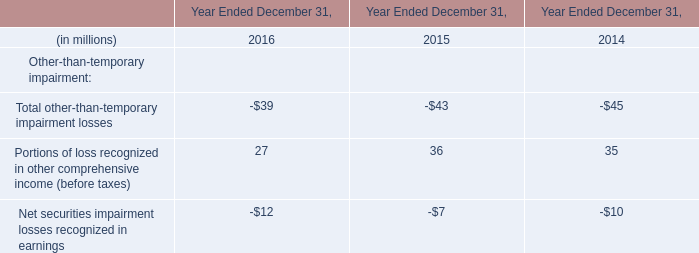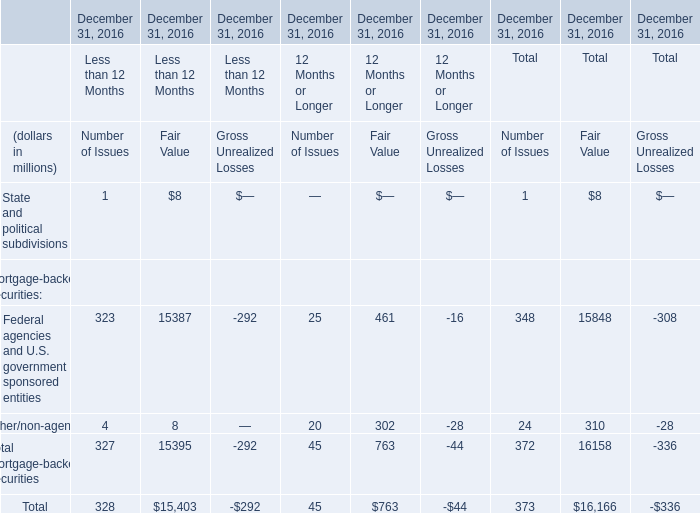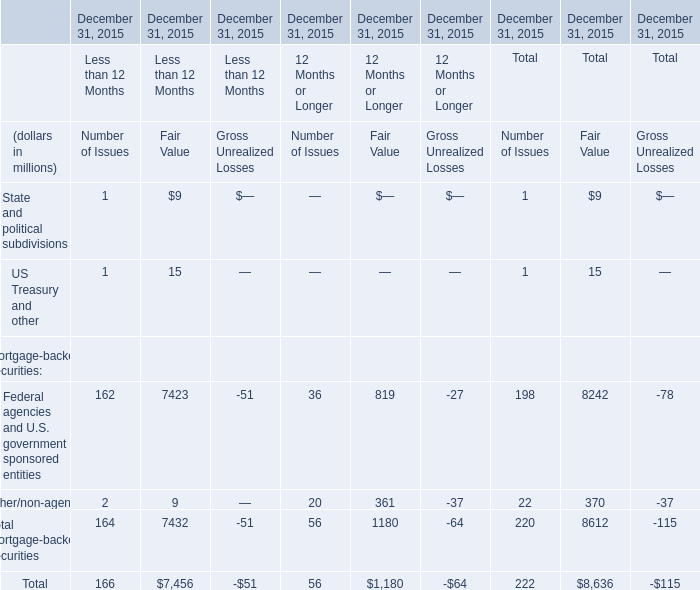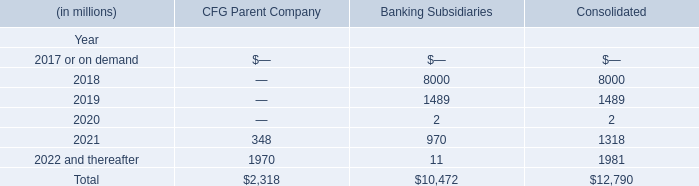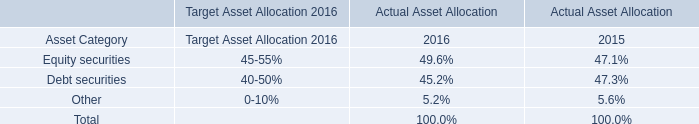What's the average of Portions of loss recognized in other comprehensive income (before taxes) in 2016 and 2015? (in million) 
Computations: ((27 + 36) / 2)
Answer: 31.5. 